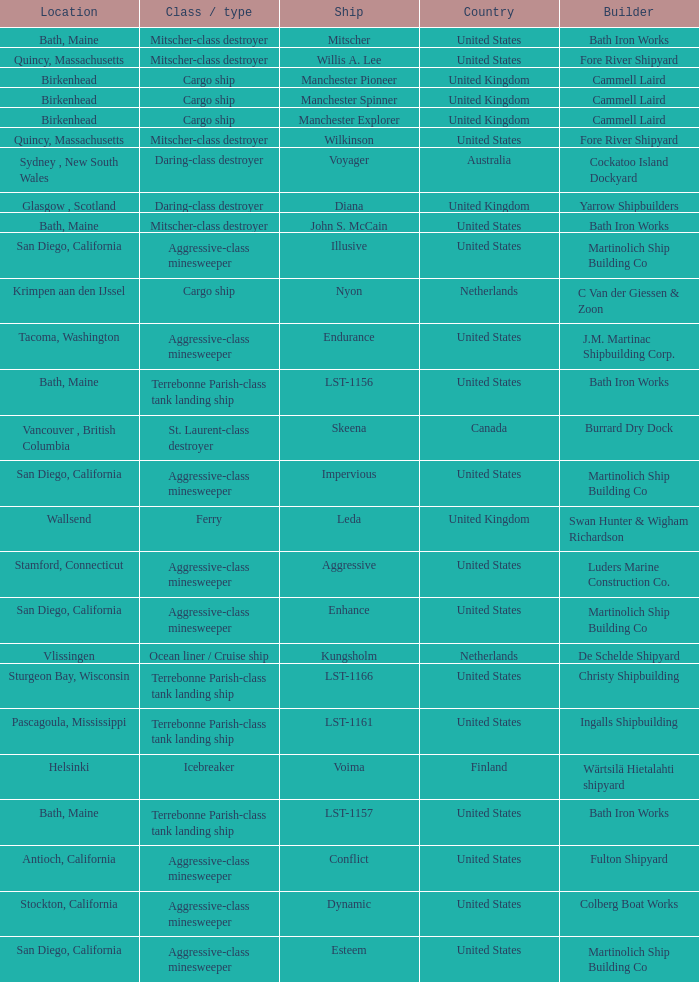Give me the full table as a dictionary. {'header': ['Location', 'Class / type', 'Ship', 'Country', 'Builder'], 'rows': [['Bath, Maine', 'Mitscher-class destroyer', 'Mitscher', 'United States', 'Bath Iron Works'], ['Quincy, Massachusetts', 'Mitscher-class destroyer', 'Willis A. Lee', 'United States', 'Fore River Shipyard'], ['Birkenhead', 'Cargo ship', 'Manchester Pioneer', 'United Kingdom', 'Cammell Laird'], ['Birkenhead', 'Cargo ship', 'Manchester Spinner', 'United Kingdom', 'Cammell Laird'], ['Birkenhead', 'Cargo ship', 'Manchester Explorer', 'United Kingdom', 'Cammell Laird'], ['Quincy, Massachusetts', 'Mitscher-class destroyer', 'Wilkinson', 'United States', 'Fore River Shipyard'], ['Sydney , New South Wales', 'Daring-class destroyer', 'Voyager', 'Australia', 'Cockatoo Island Dockyard'], ['Glasgow , Scotland', 'Daring-class destroyer', 'Diana', 'United Kingdom', 'Yarrow Shipbuilders'], ['Bath, Maine', 'Mitscher-class destroyer', 'John S. McCain', 'United States', 'Bath Iron Works'], ['San Diego, California', 'Aggressive-class minesweeper', 'Illusive', 'United States', 'Martinolich Ship Building Co'], ['Krimpen aan den IJssel', 'Cargo ship', 'Nyon', 'Netherlands', 'C Van der Giessen & Zoon'], ['Tacoma, Washington', 'Aggressive-class minesweeper', 'Endurance', 'United States', 'J.M. Martinac Shipbuilding Corp.'], ['Bath, Maine', 'Terrebonne Parish-class tank landing ship', 'LST-1156', 'United States', 'Bath Iron Works'], ['Vancouver , British Columbia', 'St. Laurent-class destroyer', 'Skeena', 'Canada', 'Burrard Dry Dock'], ['San Diego, California', 'Aggressive-class minesweeper', 'Impervious', 'United States', 'Martinolich Ship Building Co'], ['Wallsend', 'Ferry', 'Leda', 'United Kingdom', 'Swan Hunter & Wigham Richardson'], ['Stamford, Connecticut', 'Aggressive-class minesweeper', 'Aggressive', 'United States', 'Luders Marine Construction Co.'], ['San Diego, California', 'Aggressive-class minesweeper', 'Enhance', 'United States', 'Martinolich Ship Building Co'], ['Vlissingen', 'Ocean liner / Cruise ship', 'Kungsholm', 'Netherlands', 'De Schelde Shipyard'], ['Sturgeon Bay, Wisconsin', 'Terrebonne Parish-class tank landing ship', 'LST-1166', 'United States', 'Christy Shipbuilding'], ['Pascagoula, Mississippi', 'Terrebonne Parish-class tank landing ship', 'LST-1161', 'United States', 'Ingalls Shipbuilding'], ['Helsinki', 'Icebreaker', 'Voima', 'Finland', 'Wärtsilä Hietalahti shipyard'], ['Bath, Maine', 'Terrebonne Parish-class tank landing ship', 'LST-1157', 'United States', 'Bath Iron Works'], ['Antioch, California', 'Aggressive-class minesweeper', 'Conflict', 'United States', 'Fulton Shipyard'], ['Stockton, California', 'Aggressive-class minesweeper', 'Dynamic', 'United States', 'Colberg Boat Works'], ['San Diego, California', 'Aggressive-class minesweeper', 'Esteem', 'United States', 'Martinolich Ship Building Co']]} What is the Cargo Ship located at Birkenhead? Manchester Pioneer, Manchester Spinner, Manchester Explorer. 